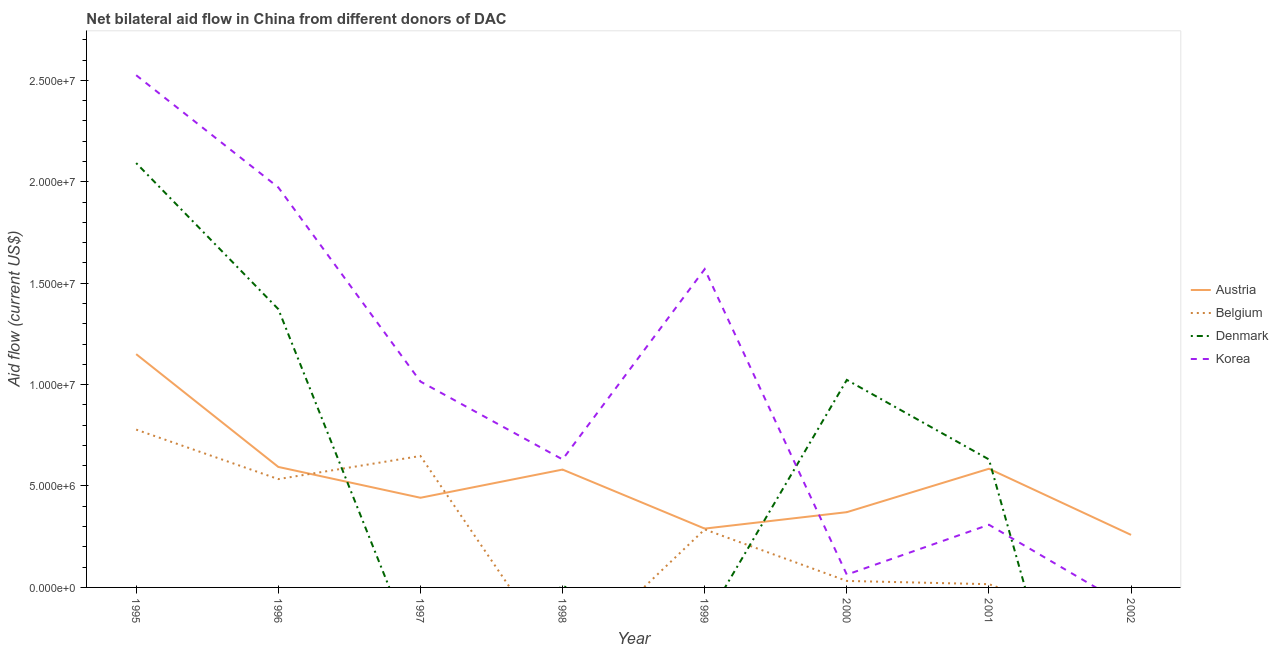Does the line corresponding to amount of aid given by denmark intersect with the line corresponding to amount of aid given by belgium?
Your answer should be very brief. Yes. What is the amount of aid given by belgium in 1999?
Your answer should be compact. 2.86e+06. Across all years, what is the maximum amount of aid given by belgium?
Give a very brief answer. 7.78e+06. Across all years, what is the minimum amount of aid given by korea?
Your response must be concise. 0. What is the total amount of aid given by korea in the graph?
Ensure brevity in your answer.  8.08e+07. What is the difference between the amount of aid given by austria in 1996 and that in 2002?
Keep it short and to the point. 3.35e+06. What is the difference between the amount of aid given by denmark in 2002 and the amount of aid given by belgium in 1999?
Offer a terse response. -2.86e+06. What is the average amount of aid given by austria per year?
Keep it short and to the point. 5.34e+06. In the year 1996, what is the difference between the amount of aid given by denmark and amount of aid given by austria?
Ensure brevity in your answer.  7.78e+06. In how many years, is the amount of aid given by belgium greater than 7000000 US$?
Your answer should be compact. 1. What is the ratio of the amount of aid given by belgium in 1995 to that in 1999?
Ensure brevity in your answer.  2.72. Is the amount of aid given by belgium in 1995 less than that in 1996?
Your answer should be very brief. No. Is the difference between the amount of aid given by denmark in 1995 and 2001 greater than the difference between the amount of aid given by austria in 1995 and 2001?
Give a very brief answer. Yes. What is the difference between the highest and the second highest amount of aid given by denmark?
Your answer should be compact. 7.20e+06. What is the difference between the highest and the lowest amount of aid given by austria?
Provide a short and direct response. 8.91e+06. Is the sum of the amount of aid given by austria in 1996 and 1998 greater than the maximum amount of aid given by korea across all years?
Provide a short and direct response. No. Does the amount of aid given by korea monotonically increase over the years?
Your answer should be very brief. No. How many lines are there?
Offer a very short reply. 4. Does the graph contain grids?
Your answer should be very brief. No. Where does the legend appear in the graph?
Your answer should be very brief. Center right. How many legend labels are there?
Give a very brief answer. 4. What is the title of the graph?
Give a very brief answer. Net bilateral aid flow in China from different donors of DAC. What is the label or title of the Y-axis?
Your answer should be very brief. Aid flow (current US$). What is the Aid flow (current US$) in Austria in 1995?
Provide a short and direct response. 1.15e+07. What is the Aid flow (current US$) of Belgium in 1995?
Offer a very short reply. 7.78e+06. What is the Aid flow (current US$) in Denmark in 1995?
Offer a terse response. 2.09e+07. What is the Aid flow (current US$) of Korea in 1995?
Your answer should be very brief. 2.52e+07. What is the Aid flow (current US$) in Austria in 1996?
Provide a succinct answer. 5.94e+06. What is the Aid flow (current US$) in Belgium in 1996?
Your response must be concise. 5.34e+06. What is the Aid flow (current US$) of Denmark in 1996?
Offer a terse response. 1.37e+07. What is the Aid flow (current US$) of Korea in 1996?
Offer a very short reply. 1.97e+07. What is the Aid flow (current US$) in Austria in 1997?
Your answer should be compact. 4.42e+06. What is the Aid flow (current US$) in Belgium in 1997?
Make the answer very short. 6.48e+06. What is the Aid flow (current US$) in Denmark in 1997?
Your answer should be very brief. 0. What is the Aid flow (current US$) of Korea in 1997?
Give a very brief answer. 1.02e+07. What is the Aid flow (current US$) in Austria in 1998?
Provide a short and direct response. 5.81e+06. What is the Aid flow (current US$) in Denmark in 1998?
Your answer should be very brief. 6.00e+04. What is the Aid flow (current US$) in Korea in 1998?
Make the answer very short. 6.31e+06. What is the Aid flow (current US$) of Austria in 1999?
Provide a succinct answer. 2.90e+06. What is the Aid flow (current US$) of Belgium in 1999?
Give a very brief answer. 2.86e+06. What is the Aid flow (current US$) of Denmark in 1999?
Your answer should be compact. 0. What is the Aid flow (current US$) of Korea in 1999?
Provide a short and direct response. 1.57e+07. What is the Aid flow (current US$) of Austria in 2000?
Your answer should be compact. 3.71e+06. What is the Aid flow (current US$) in Belgium in 2000?
Give a very brief answer. 3.20e+05. What is the Aid flow (current US$) of Denmark in 2000?
Your answer should be compact. 1.02e+07. What is the Aid flow (current US$) in Korea in 2000?
Offer a terse response. 6.30e+05. What is the Aid flow (current US$) in Austria in 2001?
Your answer should be very brief. 5.85e+06. What is the Aid flow (current US$) of Belgium in 2001?
Keep it short and to the point. 1.60e+05. What is the Aid flow (current US$) in Denmark in 2001?
Your answer should be very brief. 6.31e+06. What is the Aid flow (current US$) of Korea in 2001?
Offer a very short reply. 3.09e+06. What is the Aid flow (current US$) of Austria in 2002?
Offer a terse response. 2.59e+06. Across all years, what is the maximum Aid flow (current US$) of Austria?
Provide a short and direct response. 1.15e+07. Across all years, what is the maximum Aid flow (current US$) in Belgium?
Your answer should be compact. 7.78e+06. Across all years, what is the maximum Aid flow (current US$) in Denmark?
Give a very brief answer. 2.09e+07. Across all years, what is the maximum Aid flow (current US$) of Korea?
Make the answer very short. 2.52e+07. Across all years, what is the minimum Aid flow (current US$) in Austria?
Keep it short and to the point. 2.59e+06. Across all years, what is the minimum Aid flow (current US$) of Belgium?
Offer a very short reply. 0. Across all years, what is the minimum Aid flow (current US$) in Denmark?
Offer a terse response. 0. What is the total Aid flow (current US$) in Austria in the graph?
Offer a terse response. 4.27e+07. What is the total Aid flow (current US$) of Belgium in the graph?
Offer a very short reply. 2.29e+07. What is the total Aid flow (current US$) in Denmark in the graph?
Your answer should be very brief. 5.12e+07. What is the total Aid flow (current US$) of Korea in the graph?
Offer a terse response. 8.08e+07. What is the difference between the Aid flow (current US$) in Austria in 1995 and that in 1996?
Ensure brevity in your answer.  5.56e+06. What is the difference between the Aid flow (current US$) of Belgium in 1995 and that in 1996?
Offer a terse response. 2.44e+06. What is the difference between the Aid flow (current US$) in Denmark in 1995 and that in 1996?
Offer a terse response. 7.20e+06. What is the difference between the Aid flow (current US$) in Korea in 1995 and that in 1996?
Your answer should be compact. 5.53e+06. What is the difference between the Aid flow (current US$) of Austria in 1995 and that in 1997?
Provide a succinct answer. 7.08e+06. What is the difference between the Aid flow (current US$) of Belgium in 1995 and that in 1997?
Your answer should be compact. 1.30e+06. What is the difference between the Aid flow (current US$) of Korea in 1995 and that in 1997?
Keep it short and to the point. 1.51e+07. What is the difference between the Aid flow (current US$) of Austria in 1995 and that in 1998?
Keep it short and to the point. 5.69e+06. What is the difference between the Aid flow (current US$) in Denmark in 1995 and that in 1998?
Your answer should be very brief. 2.09e+07. What is the difference between the Aid flow (current US$) of Korea in 1995 and that in 1998?
Keep it short and to the point. 1.89e+07. What is the difference between the Aid flow (current US$) of Austria in 1995 and that in 1999?
Offer a terse response. 8.60e+06. What is the difference between the Aid flow (current US$) of Belgium in 1995 and that in 1999?
Your response must be concise. 4.92e+06. What is the difference between the Aid flow (current US$) of Korea in 1995 and that in 1999?
Your answer should be compact. 9.56e+06. What is the difference between the Aid flow (current US$) in Austria in 1995 and that in 2000?
Your response must be concise. 7.79e+06. What is the difference between the Aid flow (current US$) of Belgium in 1995 and that in 2000?
Provide a short and direct response. 7.46e+06. What is the difference between the Aid flow (current US$) of Denmark in 1995 and that in 2000?
Your answer should be very brief. 1.07e+07. What is the difference between the Aid flow (current US$) in Korea in 1995 and that in 2000?
Provide a short and direct response. 2.46e+07. What is the difference between the Aid flow (current US$) in Austria in 1995 and that in 2001?
Ensure brevity in your answer.  5.65e+06. What is the difference between the Aid flow (current US$) in Belgium in 1995 and that in 2001?
Your answer should be compact. 7.62e+06. What is the difference between the Aid flow (current US$) in Denmark in 1995 and that in 2001?
Your answer should be compact. 1.46e+07. What is the difference between the Aid flow (current US$) in Korea in 1995 and that in 2001?
Provide a short and direct response. 2.22e+07. What is the difference between the Aid flow (current US$) of Austria in 1995 and that in 2002?
Offer a very short reply. 8.91e+06. What is the difference between the Aid flow (current US$) in Austria in 1996 and that in 1997?
Your response must be concise. 1.52e+06. What is the difference between the Aid flow (current US$) in Belgium in 1996 and that in 1997?
Give a very brief answer. -1.14e+06. What is the difference between the Aid flow (current US$) of Korea in 1996 and that in 1997?
Offer a very short reply. 9.57e+06. What is the difference between the Aid flow (current US$) of Denmark in 1996 and that in 1998?
Make the answer very short. 1.37e+07. What is the difference between the Aid flow (current US$) in Korea in 1996 and that in 1998?
Your answer should be compact. 1.34e+07. What is the difference between the Aid flow (current US$) of Austria in 1996 and that in 1999?
Your answer should be compact. 3.04e+06. What is the difference between the Aid flow (current US$) of Belgium in 1996 and that in 1999?
Provide a short and direct response. 2.48e+06. What is the difference between the Aid flow (current US$) of Korea in 1996 and that in 1999?
Make the answer very short. 4.03e+06. What is the difference between the Aid flow (current US$) in Austria in 1996 and that in 2000?
Provide a short and direct response. 2.23e+06. What is the difference between the Aid flow (current US$) in Belgium in 1996 and that in 2000?
Provide a short and direct response. 5.02e+06. What is the difference between the Aid flow (current US$) in Denmark in 1996 and that in 2000?
Keep it short and to the point. 3.49e+06. What is the difference between the Aid flow (current US$) in Korea in 1996 and that in 2000?
Offer a very short reply. 1.91e+07. What is the difference between the Aid flow (current US$) of Austria in 1996 and that in 2001?
Offer a terse response. 9.00e+04. What is the difference between the Aid flow (current US$) of Belgium in 1996 and that in 2001?
Your answer should be very brief. 5.18e+06. What is the difference between the Aid flow (current US$) of Denmark in 1996 and that in 2001?
Keep it short and to the point. 7.41e+06. What is the difference between the Aid flow (current US$) of Korea in 1996 and that in 2001?
Make the answer very short. 1.66e+07. What is the difference between the Aid flow (current US$) of Austria in 1996 and that in 2002?
Your response must be concise. 3.35e+06. What is the difference between the Aid flow (current US$) of Austria in 1997 and that in 1998?
Give a very brief answer. -1.39e+06. What is the difference between the Aid flow (current US$) of Korea in 1997 and that in 1998?
Offer a very short reply. 3.84e+06. What is the difference between the Aid flow (current US$) of Austria in 1997 and that in 1999?
Keep it short and to the point. 1.52e+06. What is the difference between the Aid flow (current US$) in Belgium in 1997 and that in 1999?
Provide a succinct answer. 3.62e+06. What is the difference between the Aid flow (current US$) in Korea in 1997 and that in 1999?
Make the answer very short. -5.54e+06. What is the difference between the Aid flow (current US$) in Austria in 1997 and that in 2000?
Ensure brevity in your answer.  7.10e+05. What is the difference between the Aid flow (current US$) of Belgium in 1997 and that in 2000?
Offer a terse response. 6.16e+06. What is the difference between the Aid flow (current US$) of Korea in 1997 and that in 2000?
Provide a short and direct response. 9.52e+06. What is the difference between the Aid flow (current US$) in Austria in 1997 and that in 2001?
Provide a short and direct response. -1.43e+06. What is the difference between the Aid flow (current US$) in Belgium in 1997 and that in 2001?
Provide a succinct answer. 6.32e+06. What is the difference between the Aid flow (current US$) in Korea in 1997 and that in 2001?
Provide a succinct answer. 7.06e+06. What is the difference between the Aid flow (current US$) in Austria in 1997 and that in 2002?
Your answer should be compact. 1.83e+06. What is the difference between the Aid flow (current US$) in Austria in 1998 and that in 1999?
Offer a terse response. 2.91e+06. What is the difference between the Aid flow (current US$) in Korea in 1998 and that in 1999?
Give a very brief answer. -9.38e+06. What is the difference between the Aid flow (current US$) in Austria in 1998 and that in 2000?
Keep it short and to the point. 2.10e+06. What is the difference between the Aid flow (current US$) of Denmark in 1998 and that in 2000?
Give a very brief answer. -1.02e+07. What is the difference between the Aid flow (current US$) in Korea in 1998 and that in 2000?
Ensure brevity in your answer.  5.68e+06. What is the difference between the Aid flow (current US$) in Denmark in 1998 and that in 2001?
Offer a very short reply. -6.25e+06. What is the difference between the Aid flow (current US$) of Korea in 1998 and that in 2001?
Offer a terse response. 3.22e+06. What is the difference between the Aid flow (current US$) of Austria in 1998 and that in 2002?
Provide a short and direct response. 3.22e+06. What is the difference between the Aid flow (current US$) of Austria in 1999 and that in 2000?
Keep it short and to the point. -8.10e+05. What is the difference between the Aid flow (current US$) in Belgium in 1999 and that in 2000?
Offer a very short reply. 2.54e+06. What is the difference between the Aid flow (current US$) in Korea in 1999 and that in 2000?
Provide a short and direct response. 1.51e+07. What is the difference between the Aid flow (current US$) in Austria in 1999 and that in 2001?
Offer a very short reply. -2.95e+06. What is the difference between the Aid flow (current US$) in Belgium in 1999 and that in 2001?
Give a very brief answer. 2.70e+06. What is the difference between the Aid flow (current US$) of Korea in 1999 and that in 2001?
Offer a very short reply. 1.26e+07. What is the difference between the Aid flow (current US$) in Austria in 1999 and that in 2002?
Ensure brevity in your answer.  3.10e+05. What is the difference between the Aid flow (current US$) in Austria in 2000 and that in 2001?
Provide a short and direct response. -2.14e+06. What is the difference between the Aid flow (current US$) in Denmark in 2000 and that in 2001?
Offer a terse response. 3.92e+06. What is the difference between the Aid flow (current US$) of Korea in 2000 and that in 2001?
Provide a short and direct response. -2.46e+06. What is the difference between the Aid flow (current US$) in Austria in 2000 and that in 2002?
Offer a terse response. 1.12e+06. What is the difference between the Aid flow (current US$) of Austria in 2001 and that in 2002?
Your answer should be compact. 3.26e+06. What is the difference between the Aid flow (current US$) in Austria in 1995 and the Aid flow (current US$) in Belgium in 1996?
Give a very brief answer. 6.16e+06. What is the difference between the Aid flow (current US$) of Austria in 1995 and the Aid flow (current US$) of Denmark in 1996?
Your response must be concise. -2.22e+06. What is the difference between the Aid flow (current US$) of Austria in 1995 and the Aid flow (current US$) of Korea in 1996?
Offer a very short reply. -8.22e+06. What is the difference between the Aid flow (current US$) in Belgium in 1995 and the Aid flow (current US$) in Denmark in 1996?
Give a very brief answer. -5.94e+06. What is the difference between the Aid flow (current US$) of Belgium in 1995 and the Aid flow (current US$) of Korea in 1996?
Provide a short and direct response. -1.19e+07. What is the difference between the Aid flow (current US$) in Denmark in 1995 and the Aid flow (current US$) in Korea in 1996?
Offer a very short reply. 1.20e+06. What is the difference between the Aid flow (current US$) in Austria in 1995 and the Aid flow (current US$) in Belgium in 1997?
Your answer should be compact. 5.02e+06. What is the difference between the Aid flow (current US$) of Austria in 1995 and the Aid flow (current US$) of Korea in 1997?
Keep it short and to the point. 1.35e+06. What is the difference between the Aid flow (current US$) of Belgium in 1995 and the Aid flow (current US$) of Korea in 1997?
Keep it short and to the point. -2.37e+06. What is the difference between the Aid flow (current US$) in Denmark in 1995 and the Aid flow (current US$) in Korea in 1997?
Give a very brief answer. 1.08e+07. What is the difference between the Aid flow (current US$) in Austria in 1995 and the Aid flow (current US$) in Denmark in 1998?
Your answer should be compact. 1.14e+07. What is the difference between the Aid flow (current US$) of Austria in 1995 and the Aid flow (current US$) of Korea in 1998?
Your response must be concise. 5.19e+06. What is the difference between the Aid flow (current US$) of Belgium in 1995 and the Aid flow (current US$) of Denmark in 1998?
Make the answer very short. 7.72e+06. What is the difference between the Aid flow (current US$) of Belgium in 1995 and the Aid flow (current US$) of Korea in 1998?
Your answer should be compact. 1.47e+06. What is the difference between the Aid flow (current US$) in Denmark in 1995 and the Aid flow (current US$) in Korea in 1998?
Ensure brevity in your answer.  1.46e+07. What is the difference between the Aid flow (current US$) in Austria in 1995 and the Aid flow (current US$) in Belgium in 1999?
Your response must be concise. 8.64e+06. What is the difference between the Aid flow (current US$) of Austria in 1995 and the Aid flow (current US$) of Korea in 1999?
Your answer should be compact. -4.19e+06. What is the difference between the Aid flow (current US$) in Belgium in 1995 and the Aid flow (current US$) in Korea in 1999?
Your answer should be compact. -7.91e+06. What is the difference between the Aid flow (current US$) of Denmark in 1995 and the Aid flow (current US$) of Korea in 1999?
Provide a short and direct response. 5.23e+06. What is the difference between the Aid flow (current US$) of Austria in 1995 and the Aid flow (current US$) of Belgium in 2000?
Your response must be concise. 1.12e+07. What is the difference between the Aid flow (current US$) in Austria in 1995 and the Aid flow (current US$) in Denmark in 2000?
Provide a short and direct response. 1.27e+06. What is the difference between the Aid flow (current US$) in Austria in 1995 and the Aid flow (current US$) in Korea in 2000?
Provide a succinct answer. 1.09e+07. What is the difference between the Aid flow (current US$) in Belgium in 1995 and the Aid flow (current US$) in Denmark in 2000?
Provide a succinct answer. -2.45e+06. What is the difference between the Aid flow (current US$) in Belgium in 1995 and the Aid flow (current US$) in Korea in 2000?
Your response must be concise. 7.15e+06. What is the difference between the Aid flow (current US$) of Denmark in 1995 and the Aid flow (current US$) of Korea in 2000?
Keep it short and to the point. 2.03e+07. What is the difference between the Aid flow (current US$) of Austria in 1995 and the Aid flow (current US$) of Belgium in 2001?
Provide a succinct answer. 1.13e+07. What is the difference between the Aid flow (current US$) of Austria in 1995 and the Aid flow (current US$) of Denmark in 2001?
Offer a very short reply. 5.19e+06. What is the difference between the Aid flow (current US$) in Austria in 1995 and the Aid flow (current US$) in Korea in 2001?
Make the answer very short. 8.41e+06. What is the difference between the Aid flow (current US$) of Belgium in 1995 and the Aid flow (current US$) of Denmark in 2001?
Your response must be concise. 1.47e+06. What is the difference between the Aid flow (current US$) of Belgium in 1995 and the Aid flow (current US$) of Korea in 2001?
Provide a short and direct response. 4.69e+06. What is the difference between the Aid flow (current US$) of Denmark in 1995 and the Aid flow (current US$) of Korea in 2001?
Provide a short and direct response. 1.78e+07. What is the difference between the Aid flow (current US$) of Austria in 1996 and the Aid flow (current US$) of Belgium in 1997?
Your answer should be very brief. -5.40e+05. What is the difference between the Aid flow (current US$) of Austria in 1996 and the Aid flow (current US$) of Korea in 1997?
Offer a very short reply. -4.21e+06. What is the difference between the Aid flow (current US$) in Belgium in 1996 and the Aid flow (current US$) in Korea in 1997?
Make the answer very short. -4.81e+06. What is the difference between the Aid flow (current US$) of Denmark in 1996 and the Aid flow (current US$) of Korea in 1997?
Give a very brief answer. 3.57e+06. What is the difference between the Aid flow (current US$) of Austria in 1996 and the Aid flow (current US$) of Denmark in 1998?
Keep it short and to the point. 5.88e+06. What is the difference between the Aid flow (current US$) of Austria in 1996 and the Aid flow (current US$) of Korea in 1998?
Offer a very short reply. -3.70e+05. What is the difference between the Aid flow (current US$) of Belgium in 1996 and the Aid flow (current US$) of Denmark in 1998?
Provide a succinct answer. 5.28e+06. What is the difference between the Aid flow (current US$) in Belgium in 1996 and the Aid flow (current US$) in Korea in 1998?
Offer a terse response. -9.70e+05. What is the difference between the Aid flow (current US$) of Denmark in 1996 and the Aid flow (current US$) of Korea in 1998?
Provide a short and direct response. 7.41e+06. What is the difference between the Aid flow (current US$) of Austria in 1996 and the Aid flow (current US$) of Belgium in 1999?
Offer a terse response. 3.08e+06. What is the difference between the Aid flow (current US$) in Austria in 1996 and the Aid flow (current US$) in Korea in 1999?
Give a very brief answer. -9.75e+06. What is the difference between the Aid flow (current US$) in Belgium in 1996 and the Aid flow (current US$) in Korea in 1999?
Your answer should be compact. -1.04e+07. What is the difference between the Aid flow (current US$) in Denmark in 1996 and the Aid flow (current US$) in Korea in 1999?
Offer a very short reply. -1.97e+06. What is the difference between the Aid flow (current US$) of Austria in 1996 and the Aid flow (current US$) of Belgium in 2000?
Provide a succinct answer. 5.62e+06. What is the difference between the Aid flow (current US$) in Austria in 1996 and the Aid flow (current US$) in Denmark in 2000?
Keep it short and to the point. -4.29e+06. What is the difference between the Aid flow (current US$) of Austria in 1996 and the Aid flow (current US$) of Korea in 2000?
Keep it short and to the point. 5.31e+06. What is the difference between the Aid flow (current US$) of Belgium in 1996 and the Aid flow (current US$) of Denmark in 2000?
Your answer should be compact. -4.89e+06. What is the difference between the Aid flow (current US$) in Belgium in 1996 and the Aid flow (current US$) in Korea in 2000?
Keep it short and to the point. 4.71e+06. What is the difference between the Aid flow (current US$) of Denmark in 1996 and the Aid flow (current US$) of Korea in 2000?
Offer a terse response. 1.31e+07. What is the difference between the Aid flow (current US$) of Austria in 1996 and the Aid flow (current US$) of Belgium in 2001?
Offer a terse response. 5.78e+06. What is the difference between the Aid flow (current US$) of Austria in 1996 and the Aid flow (current US$) of Denmark in 2001?
Keep it short and to the point. -3.70e+05. What is the difference between the Aid flow (current US$) in Austria in 1996 and the Aid flow (current US$) in Korea in 2001?
Your answer should be compact. 2.85e+06. What is the difference between the Aid flow (current US$) in Belgium in 1996 and the Aid flow (current US$) in Denmark in 2001?
Provide a succinct answer. -9.70e+05. What is the difference between the Aid flow (current US$) in Belgium in 1996 and the Aid flow (current US$) in Korea in 2001?
Make the answer very short. 2.25e+06. What is the difference between the Aid flow (current US$) of Denmark in 1996 and the Aid flow (current US$) of Korea in 2001?
Give a very brief answer. 1.06e+07. What is the difference between the Aid flow (current US$) of Austria in 1997 and the Aid flow (current US$) of Denmark in 1998?
Offer a very short reply. 4.36e+06. What is the difference between the Aid flow (current US$) of Austria in 1997 and the Aid flow (current US$) of Korea in 1998?
Keep it short and to the point. -1.89e+06. What is the difference between the Aid flow (current US$) in Belgium in 1997 and the Aid flow (current US$) in Denmark in 1998?
Your answer should be very brief. 6.42e+06. What is the difference between the Aid flow (current US$) in Austria in 1997 and the Aid flow (current US$) in Belgium in 1999?
Offer a terse response. 1.56e+06. What is the difference between the Aid flow (current US$) in Austria in 1997 and the Aid flow (current US$) in Korea in 1999?
Ensure brevity in your answer.  -1.13e+07. What is the difference between the Aid flow (current US$) in Belgium in 1997 and the Aid flow (current US$) in Korea in 1999?
Your answer should be compact. -9.21e+06. What is the difference between the Aid flow (current US$) in Austria in 1997 and the Aid flow (current US$) in Belgium in 2000?
Make the answer very short. 4.10e+06. What is the difference between the Aid flow (current US$) of Austria in 1997 and the Aid flow (current US$) of Denmark in 2000?
Make the answer very short. -5.81e+06. What is the difference between the Aid flow (current US$) of Austria in 1997 and the Aid flow (current US$) of Korea in 2000?
Provide a succinct answer. 3.79e+06. What is the difference between the Aid flow (current US$) in Belgium in 1997 and the Aid flow (current US$) in Denmark in 2000?
Provide a succinct answer. -3.75e+06. What is the difference between the Aid flow (current US$) in Belgium in 1997 and the Aid flow (current US$) in Korea in 2000?
Offer a very short reply. 5.85e+06. What is the difference between the Aid flow (current US$) in Austria in 1997 and the Aid flow (current US$) in Belgium in 2001?
Keep it short and to the point. 4.26e+06. What is the difference between the Aid flow (current US$) in Austria in 1997 and the Aid flow (current US$) in Denmark in 2001?
Provide a short and direct response. -1.89e+06. What is the difference between the Aid flow (current US$) in Austria in 1997 and the Aid flow (current US$) in Korea in 2001?
Provide a short and direct response. 1.33e+06. What is the difference between the Aid flow (current US$) in Belgium in 1997 and the Aid flow (current US$) in Denmark in 2001?
Offer a terse response. 1.70e+05. What is the difference between the Aid flow (current US$) in Belgium in 1997 and the Aid flow (current US$) in Korea in 2001?
Ensure brevity in your answer.  3.39e+06. What is the difference between the Aid flow (current US$) in Austria in 1998 and the Aid flow (current US$) in Belgium in 1999?
Your answer should be very brief. 2.95e+06. What is the difference between the Aid flow (current US$) in Austria in 1998 and the Aid flow (current US$) in Korea in 1999?
Your answer should be very brief. -9.88e+06. What is the difference between the Aid flow (current US$) of Denmark in 1998 and the Aid flow (current US$) of Korea in 1999?
Make the answer very short. -1.56e+07. What is the difference between the Aid flow (current US$) in Austria in 1998 and the Aid flow (current US$) in Belgium in 2000?
Provide a short and direct response. 5.49e+06. What is the difference between the Aid flow (current US$) in Austria in 1998 and the Aid flow (current US$) in Denmark in 2000?
Offer a very short reply. -4.42e+06. What is the difference between the Aid flow (current US$) of Austria in 1998 and the Aid flow (current US$) of Korea in 2000?
Provide a succinct answer. 5.18e+06. What is the difference between the Aid flow (current US$) in Denmark in 1998 and the Aid flow (current US$) in Korea in 2000?
Ensure brevity in your answer.  -5.70e+05. What is the difference between the Aid flow (current US$) of Austria in 1998 and the Aid flow (current US$) of Belgium in 2001?
Offer a very short reply. 5.65e+06. What is the difference between the Aid flow (current US$) in Austria in 1998 and the Aid flow (current US$) in Denmark in 2001?
Give a very brief answer. -5.00e+05. What is the difference between the Aid flow (current US$) in Austria in 1998 and the Aid flow (current US$) in Korea in 2001?
Give a very brief answer. 2.72e+06. What is the difference between the Aid flow (current US$) in Denmark in 1998 and the Aid flow (current US$) in Korea in 2001?
Your answer should be compact. -3.03e+06. What is the difference between the Aid flow (current US$) of Austria in 1999 and the Aid flow (current US$) of Belgium in 2000?
Your response must be concise. 2.58e+06. What is the difference between the Aid flow (current US$) in Austria in 1999 and the Aid flow (current US$) in Denmark in 2000?
Your answer should be very brief. -7.33e+06. What is the difference between the Aid flow (current US$) of Austria in 1999 and the Aid flow (current US$) of Korea in 2000?
Offer a very short reply. 2.27e+06. What is the difference between the Aid flow (current US$) of Belgium in 1999 and the Aid flow (current US$) of Denmark in 2000?
Make the answer very short. -7.37e+06. What is the difference between the Aid flow (current US$) of Belgium in 1999 and the Aid flow (current US$) of Korea in 2000?
Ensure brevity in your answer.  2.23e+06. What is the difference between the Aid flow (current US$) of Austria in 1999 and the Aid flow (current US$) of Belgium in 2001?
Your answer should be very brief. 2.74e+06. What is the difference between the Aid flow (current US$) of Austria in 1999 and the Aid flow (current US$) of Denmark in 2001?
Give a very brief answer. -3.41e+06. What is the difference between the Aid flow (current US$) of Belgium in 1999 and the Aid flow (current US$) of Denmark in 2001?
Make the answer very short. -3.45e+06. What is the difference between the Aid flow (current US$) in Belgium in 1999 and the Aid flow (current US$) in Korea in 2001?
Provide a succinct answer. -2.30e+05. What is the difference between the Aid flow (current US$) in Austria in 2000 and the Aid flow (current US$) in Belgium in 2001?
Provide a succinct answer. 3.55e+06. What is the difference between the Aid flow (current US$) in Austria in 2000 and the Aid flow (current US$) in Denmark in 2001?
Give a very brief answer. -2.60e+06. What is the difference between the Aid flow (current US$) of Austria in 2000 and the Aid flow (current US$) of Korea in 2001?
Your answer should be compact. 6.20e+05. What is the difference between the Aid flow (current US$) in Belgium in 2000 and the Aid flow (current US$) in Denmark in 2001?
Your answer should be compact. -5.99e+06. What is the difference between the Aid flow (current US$) in Belgium in 2000 and the Aid flow (current US$) in Korea in 2001?
Provide a succinct answer. -2.77e+06. What is the difference between the Aid flow (current US$) of Denmark in 2000 and the Aid flow (current US$) of Korea in 2001?
Keep it short and to the point. 7.14e+06. What is the average Aid flow (current US$) in Austria per year?
Offer a terse response. 5.34e+06. What is the average Aid flow (current US$) of Belgium per year?
Your answer should be very brief. 2.87e+06. What is the average Aid flow (current US$) in Denmark per year?
Keep it short and to the point. 6.40e+06. What is the average Aid flow (current US$) in Korea per year?
Give a very brief answer. 1.01e+07. In the year 1995, what is the difference between the Aid flow (current US$) of Austria and Aid flow (current US$) of Belgium?
Your response must be concise. 3.72e+06. In the year 1995, what is the difference between the Aid flow (current US$) in Austria and Aid flow (current US$) in Denmark?
Keep it short and to the point. -9.42e+06. In the year 1995, what is the difference between the Aid flow (current US$) of Austria and Aid flow (current US$) of Korea?
Your answer should be compact. -1.38e+07. In the year 1995, what is the difference between the Aid flow (current US$) in Belgium and Aid flow (current US$) in Denmark?
Provide a short and direct response. -1.31e+07. In the year 1995, what is the difference between the Aid flow (current US$) of Belgium and Aid flow (current US$) of Korea?
Offer a terse response. -1.75e+07. In the year 1995, what is the difference between the Aid flow (current US$) in Denmark and Aid flow (current US$) in Korea?
Offer a very short reply. -4.33e+06. In the year 1996, what is the difference between the Aid flow (current US$) in Austria and Aid flow (current US$) in Belgium?
Keep it short and to the point. 6.00e+05. In the year 1996, what is the difference between the Aid flow (current US$) in Austria and Aid flow (current US$) in Denmark?
Ensure brevity in your answer.  -7.78e+06. In the year 1996, what is the difference between the Aid flow (current US$) in Austria and Aid flow (current US$) in Korea?
Offer a very short reply. -1.38e+07. In the year 1996, what is the difference between the Aid flow (current US$) in Belgium and Aid flow (current US$) in Denmark?
Offer a terse response. -8.38e+06. In the year 1996, what is the difference between the Aid flow (current US$) in Belgium and Aid flow (current US$) in Korea?
Make the answer very short. -1.44e+07. In the year 1996, what is the difference between the Aid flow (current US$) in Denmark and Aid flow (current US$) in Korea?
Offer a terse response. -6.00e+06. In the year 1997, what is the difference between the Aid flow (current US$) of Austria and Aid flow (current US$) of Belgium?
Your answer should be compact. -2.06e+06. In the year 1997, what is the difference between the Aid flow (current US$) in Austria and Aid flow (current US$) in Korea?
Offer a terse response. -5.73e+06. In the year 1997, what is the difference between the Aid flow (current US$) in Belgium and Aid flow (current US$) in Korea?
Offer a terse response. -3.67e+06. In the year 1998, what is the difference between the Aid flow (current US$) in Austria and Aid flow (current US$) in Denmark?
Your response must be concise. 5.75e+06. In the year 1998, what is the difference between the Aid flow (current US$) of Austria and Aid flow (current US$) of Korea?
Your response must be concise. -5.00e+05. In the year 1998, what is the difference between the Aid flow (current US$) in Denmark and Aid flow (current US$) in Korea?
Keep it short and to the point. -6.25e+06. In the year 1999, what is the difference between the Aid flow (current US$) of Austria and Aid flow (current US$) of Belgium?
Provide a short and direct response. 4.00e+04. In the year 1999, what is the difference between the Aid flow (current US$) of Austria and Aid flow (current US$) of Korea?
Your answer should be compact. -1.28e+07. In the year 1999, what is the difference between the Aid flow (current US$) in Belgium and Aid flow (current US$) in Korea?
Keep it short and to the point. -1.28e+07. In the year 2000, what is the difference between the Aid flow (current US$) of Austria and Aid flow (current US$) of Belgium?
Provide a short and direct response. 3.39e+06. In the year 2000, what is the difference between the Aid flow (current US$) of Austria and Aid flow (current US$) of Denmark?
Offer a terse response. -6.52e+06. In the year 2000, what is the difference between the Aid flow (current US$) of Austria and Aid flow (current US$) of Korea?
Make the answer very short. 3.08e+06. In the year 2000, what is the difference between the Aid flow (current US$) in Belgium and Aid flow (current US$) in Denmark?
Provide a succinct answer. -9.91e+06. In the year 2000, what is the difference between the Aid flow (current US$) of Belgium and Aid flow (current US$) of Korea?
Provide a succinct answer. -3.10e+05. In the year 2000, what is the difference between the Aid flow (current US$) in Denmark and Aid flow (current US$) in Korea?
Your response must be concise. 9.60e+06. In the year 2001, what is the difference between the Aid flow (current US$) in Austria and Aid flow (current US$) in Belgium?
Provide a succinct answer. 5.69e+06. In the year 2001, what is the difference between the Aid flow (current US$) in Austria and Aid flow (current US$) in Denmark?
Offer a very short reply. -4.60e+05. In the year 2001, what is the difference between the Aid flow (current US$) in Austria and Aid flow (current US$) in Korea?
Make the answer very short. 2.76e+06. In the year 2001, what is the difference between the Aid flow (current US$) in Belgium and Aid flow (current US$) in Denmark?
Offer a very short reply. -6.15e+06. In the year 2001, what is the difference between the Aid flow (current US$) of Belgium and Aid flow (current US$) of Korea?
Offer a terse response. -2.93e+06. In the year 2001, what is the difference between the Aid flow (current US$) of Denmark and Aid flow (current US$) of Korea?
Ensure brevity in your answer.  3.22e+06. What is the ratio of the Aid flow (current US$) in Austria in 1995 to that in 1996?
Offer a very short reply. 1.94. What is the ratio of the Aid flow (current US$) of Belgium in 1995 to that in 1996?
Your answer should be very brief. 1.46. What is the ratio of the Aid flow (current US$) in Denmark in 1995 to that in 1996?
Give a very brief answer. 1.52. What is the ratio of the Aid flow (current US$) of Korea in 1995 to that in 1996?
Your answer should be very brief. 1.28. What is the ratio of the Aid flow (current US$) in Austria in 1995 to that in 1997?
Your answer should be very brief. 2.6. What is the ratio of the Aid flow (current US$) in Belgium in 1995 to that in 1997?
Your answer should be very brief. 1.2. What is the ratio of the Aid flow (current US$) in Korea in 1995 to that in 1997?
Make the answer very short. 2.49. What is the ratio of the Aid flow (current US$) in Austria in 1995 to that in 1998?
Keep it short and to the point. 1.98. What is the ratio of the Aid flow (current US$) in Denmark in 1995 to that in 1998?
Provide a succinct answer. 348.67. What is the ratio of the Aid flow (current US$) of Korea in 1995 to that in 1998?
Provide a succinct answer. 4. What is the ratio of the Aid flow (current US$) in Austria in 1995 to that in 1999?
Offer a terse response. 3.97. What is the ratio of the Aid flow (current US$) in Belgium in 1995 to that in 1999?
Provide a succinct answer. 2.72. What is the ratio of the Aid flow (current US$) in Korea in 1995 to that in 1999?
Provide a succinct answer. 1.61. What is the ratio of the Aid flow (current US$) in Austria in 1995 to that in 2000?
Make the answer very short. 3.1. What is the ratio of the Aid flow (current US$) in Belgium in 1995 to that in 2000?
Offer a very short reply. 24.31. What is the ratio of the Aid flow (current US$) of Denmark in 1995 to that in 2000?
Ensure brevity in your answer.  2.04. What is the ratio of the Aid flow (current US$) in Korea in 1995 to that in 2000?
Keep it short and to the point. 40.08. What is the ratio of the Aid flow (current US$) in Austria in 1995 to that in 2001?
Your response must be concise. 1.97. What is the ratio of the Aid flow (current US$) of Belgium in 1995 to that in 2001?
Offer a very short reply. 48.62. What is the ratio of the Aid flow (current US$) in Denmark in 1995 to that in 2001?
Provide a succinct answer. 3.32. What is the ratio of the Aid flow (current US$) in Korea in 1995 to that in 2001?
Your answer should be compact. 8.17. What is the ratio of the Aid flow (current US$) of Austria in 1995 to that in 2002?
Give a very brief answer. 4.44. What is the ratio of the Aid flow (current US$) of Austria in 1996 to that in 1997?
Provide a succinct answer. 1.34. What is the ratio of the Aid flow (current US$) in Belgium in 1996 to that in 1997?
Offer a very short reply. 0.82. What is the ratio of the Aid flow (current US$) in Korea in 1996 to that in 1997?
Offer a terse response. 1.94. What is the ratio of the Aid flow (current US$) of Austria in 1996 to that in 1998?
Keep it short and to the point. 1.02. What is the ratio of the Aid flow (current US$) of Denmark in 1996 to that in 1998?
Provide a short and direct response. 228.67. What is the ratio of the Aid flow (current US$) in Korea in 1996 to that in 1998?
Give a very brief answer. 3.13. What is the ratio of the Aid flow (current US$) in Austria in 1996 to that in 1999?
Your answer should be compact. 2.05. What is the ratio of the Aid flow (current US$) of Belgium in 1996 to that in 1999?
Offer a terse response. 1.87. What is the ratio of the Aid flow (current US$) in Korea in 1996 to that in 1999?
Your answer should be very brief. 1.26. What is the ratio of the Aid flow (current US$) of Austria in 1996 to that in 2000?
Your response must be concise. 1.6. What is the ratio of the Aid flow (current US$) in Belgium in 1996 to that in 2000?
Offer a terse response. 16.69. What is the ratio of the Aid flow (current US$) of Denmark in 1996 to that in 2000?
Make the answer very short. 1.34. What is the ratio of the Aid flow (current US$) of Korea in 1996 to that in 2000?
Make the answer very short. 31.3. What is the ratio of the Aid flow (current US$) of Austria in 1996 to that in 2001?
Offer a terse response. 1.02. What is the ratio of the Aid flow (current US$) in Belgium in 1996 to that in 2001?
Ensure brevity in your answer.  33.38. What is the ratio of the Aid flow (current US$) in Denmark in 1996 to that in 2001?
Provide a succinct answer. 2.17. What is the ratio of the Aid flow (current US$) of Korea in 1996 to that in 2001?
Make the answer very short. 6.38. What is the ratio of the Aid flow (current US$) of Austria in 1996 to that in 2002?
Keep it short and to the point. 2.29. What is the ratio of the Aid flow (current US$) of Austria in 1997 to that in 1998?
Ensure brevity in your answer.  0.76. What is the ratio of the Aid flow (current US$) of Korea in 1997 to that in 1998?
Your answer should be compact. 1.61. What is the ratio of the Aid flow (current US$) of Austria in 1997 to that in 1999?
Your response must be concise. 1.52. What is the ratio of the Aid flow (current US$) of Belgium in 1997 to that in 1999?
Offer a terse response. 2.27. What is the ratio of the Aid flow (current US$) of Korea in 1997 to that in 1999?
Keep it short and to the point. 0.65. What is the ratio of the Aid flow (current US$) of Austria in 1997 to that in 2000?
Keep it short and to the point. 1.19. What is the ratio of the Aid flow (current US$) in Belgium in 1997 to that in 2000?
Provide a short and direct response. 20.25. What is the ratio of the Aid flow (current US$) of Korea in 1997 to that in 2000?
Provide a short and direct response. 16.11. What is the ratio of the Aid flow (current US$) of Austria in 1997 to that in 2001?
Give a very brief answer. 0.76. What is the ratio of the Aid flow (current US$) in Belgium in 1997 to that in 2001?
Offer a terse response. 40.5. What is the ratio of the Aid flow (current US$) of Korea in 1997 to that in 2001?
Give a very brief answer. 3.28. What is the ratio of the Aid flow (current US$) of Austria in 1997 to that in 2002?
Your response must be concise. 1.71. What is the ratio of the Aid flow (current US$) in Austria in 1998 to that in 1999?
Give a very brief answer. 2. What is the ratio of the Aid flow (current US$) in Korea in 1998 to that in 1999?
Your answer should be compact. 0.4. What is the ratio of the Aid flow (current US$) in Austria in 1998 to that in 2000?
Keep it short and to the point. 1.57. What is the ratio of the Aid flow (current US$) of Denmark in 1998 to that in 2000?
Make the answer very short. 0.01. What is the ratio of the Aid flow (current US$) in Korea in 1998 to that in 2000?
Provide a short and direct response. 10.02. What is the ratio of the Aid flow (current US$) of Austria in 1998 to that in 2001?
Your answer should be very brief. 0.99. What is the ratio of the Aid flow (current US$) in Denmark in 1998 to that in 2001?
Your answer should be compact. 0.01. What is the ratio of the Aid flow (current US$) of Korea in 1998 to that in 2001?
Offer a terse response. 2.04. What is the ratio of the Aid flow (current US$) of Austria in 1998 to that in 2002?
Your answer should be very brief. 2.24. What is the ratio of the Aid flow (current US$) in Austria in 1999 to that in 2000?
Your response must be concise. 0.78. What is the ratio of the Aid flow (current US$) of Belgium in 1999 to that in 2000?
Your answer should be compact. 8.94. What is the ratio of the Aid flow (current US$) in Korea in 1999 to that in 2000?
Keep it short and to the point. 24.9. What is the ratio of the Aid flow (current US$) in Austria in 1999 to that in 2001?
Your answer should be very brief. 0.5. What is the ratio of the Aid flow (current US$) in Belgium in 1999 to that in 2001?
Your answer should be very brief. 17.88. What is the ratio of the Aid flow (current US$) of Korea in 1999 to that in 2001?
Provide a short and direct response. 5.08. What is the ratio of the Aid flow (current US$) in Austria in 1999 to that in 2002?
Provide a short and direct response. 1.12. What is the ratio of the Aid flow (current US$) in Austria in 2000 to that in 2001?
Your answer should be compact. 0.63. What is the ratio of the Aid flow (current US$) in Belgium in 2000 to that in 2001?
Give a very brief answer. 2. What is the ratio of the Aid flow (current US$) of Denmark in 2000 to that in 2001?
Your answer should be very brief. 1.62. What is the ratio of the Aid flow (current US$) in Korea in 2000 to that in 2001?
Provide a succinct answer. 0.2. What is the ratio of the Aid flow (current US$) in Austria in 2000 to that in 2002?
Offer a very short reply. 1.43. What is the ratio of the Aid flow (current US$) in Austria in 2001 to that in 2002?
Provide a short and direct response. 2.26. What is the difference between the highest and the second highest Aid flow (current US$) of Austria?
Your response must be concise. 5.56e+06. What is the difference between the highest and the second highest Aid flow (current US$) in Belgium?
Offer a terse response. 1.30e+06. What is the difference between the highest and the second highest Aid flow (current US$) of Denmark?
Your answer should be compact. 7.20e+06. What is the difference between the highest and the second highest Aid flow (current US$) in Korea?
Offer a very short reply. 5.53e+06. What is the difference between the highest and the lowest Aid flow (current US$) of Austria?
Ensure brevity in your answer.  8.91e+06. What is the difference between the highest and the lowest Aid flow (current US$) in Belgium?
Provide a short and direct response. 7.78e+06. What is the difference between the highest and the lowest Aid flow (current US$) in Denmark?
Provide a short and direct response. 2.09e+07. What is the difference between the highest and the lowest Aid flow (current US$) of Korea?
Offer a terse response. 2.52e+07. 